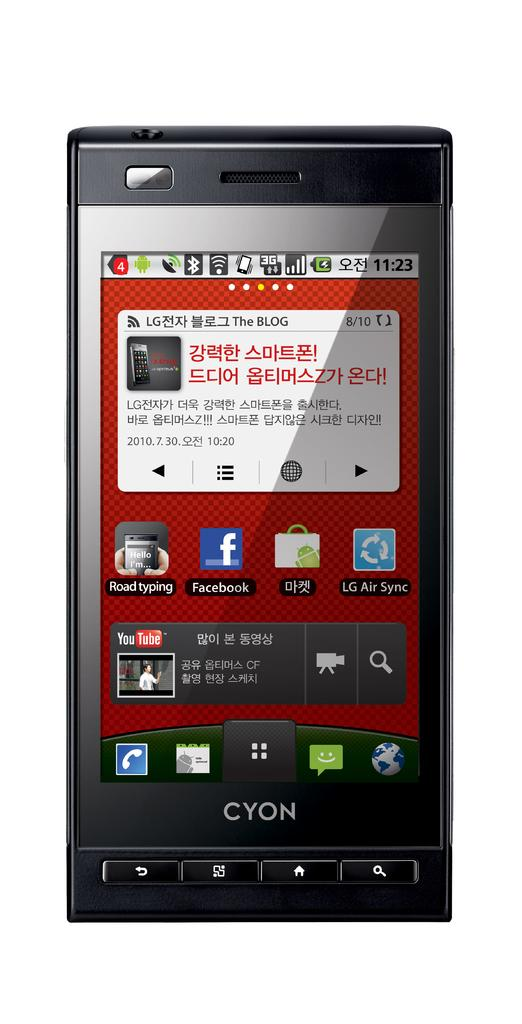<image>
Render a clear and concise summary of the photo. a black Cyon cell phone with a Japanese text message 